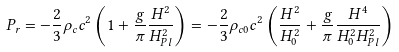<formula> <loc_0><loc_0><loc_500><loc_500>P _ { r } = - \frac { 2 } { 3 } \rho _ { c } c ^ { 2 } \left ( 1 + \frac { g } { \pi } \frac { H ^ { 2 } } { H _ { P l } ^ { 2 } } \right ) = - \frac { 2 } { 3 } \rho _ { c 0 } c ^ { 2 } \left ( \frac { H ^ { 2 } } { H _ { 0 } ^ { 2 } } + \frac { g } { \pi } \frac { H ^ { 4 } } { H _ { 0 } ^ { 2 } H _ { P l } ^ { 2 } } \right )</formula> 